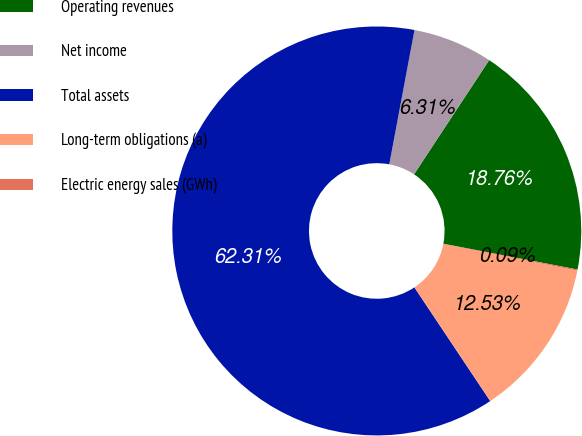<chart> <loc_0><loc_0><loc_500><loc_500><pie_chart><fcel>Operating revenues<fcel>Net income<fcel>Total assets<fcel>Long-term obligations (a)<fcel>Electric energy sales (GWh)<nl><fcel>18.76%<fcel>6.31%<fcel>62.32%<fcel>12.53%<fcel>0.09%<nl></chart> 